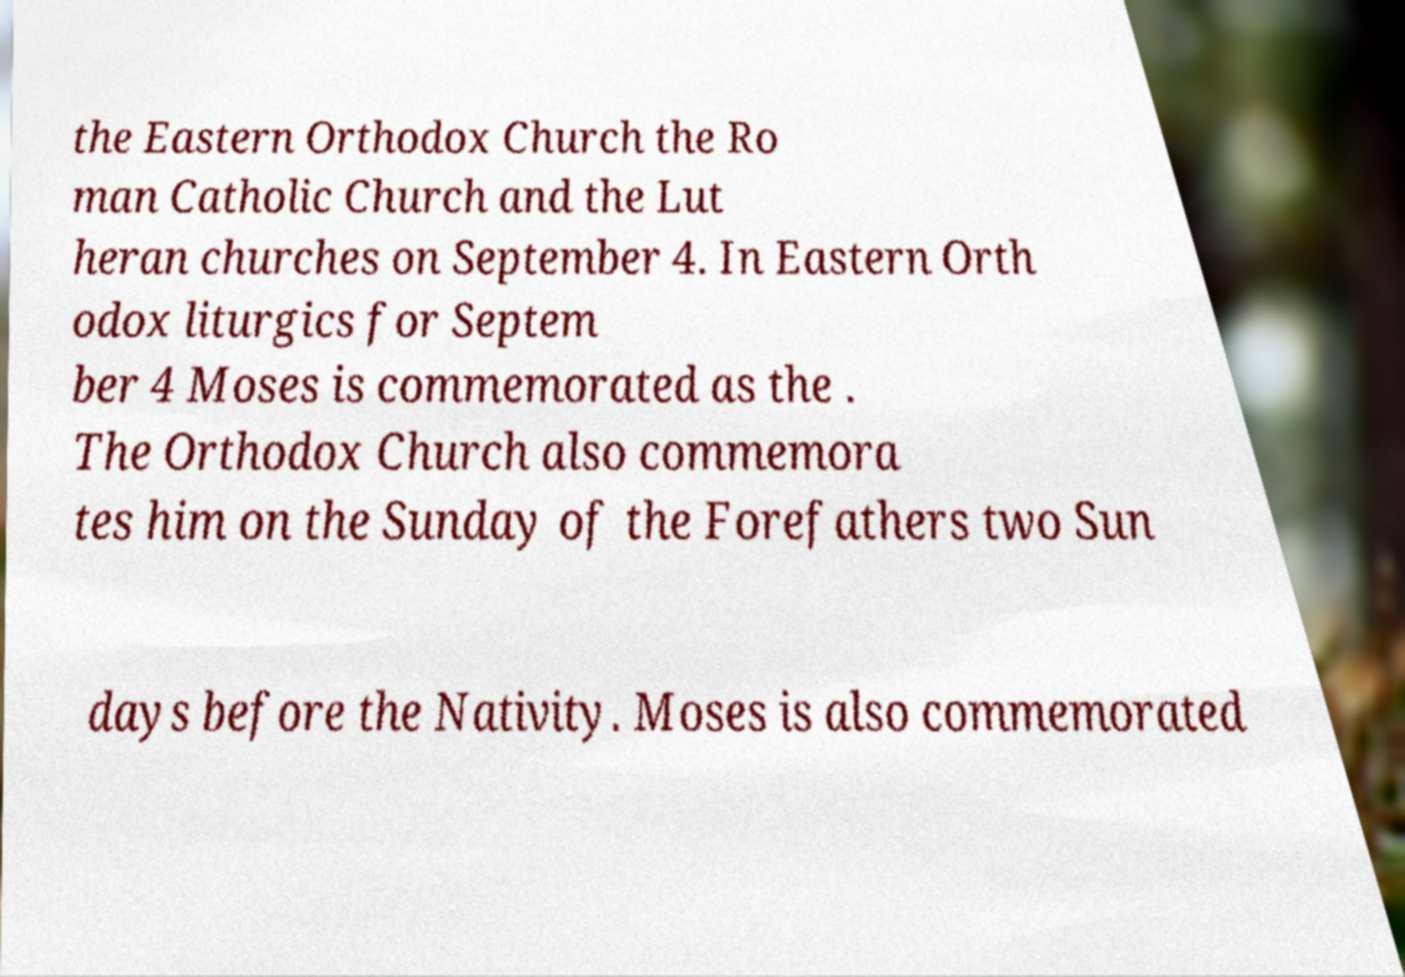Please identify and transcribe the text found in this image. the Eastern Orthodox Church the Ro man Catholic Church and the Lut heran churches on September 4. In Eastern Orth odox liturgics for Septem ber 4 Moses is commemorated as the . The Orthodox Church also commemora tes him on the Sunday of the Forefathers two Sun days before the Nativity. Moses is also commemorated 